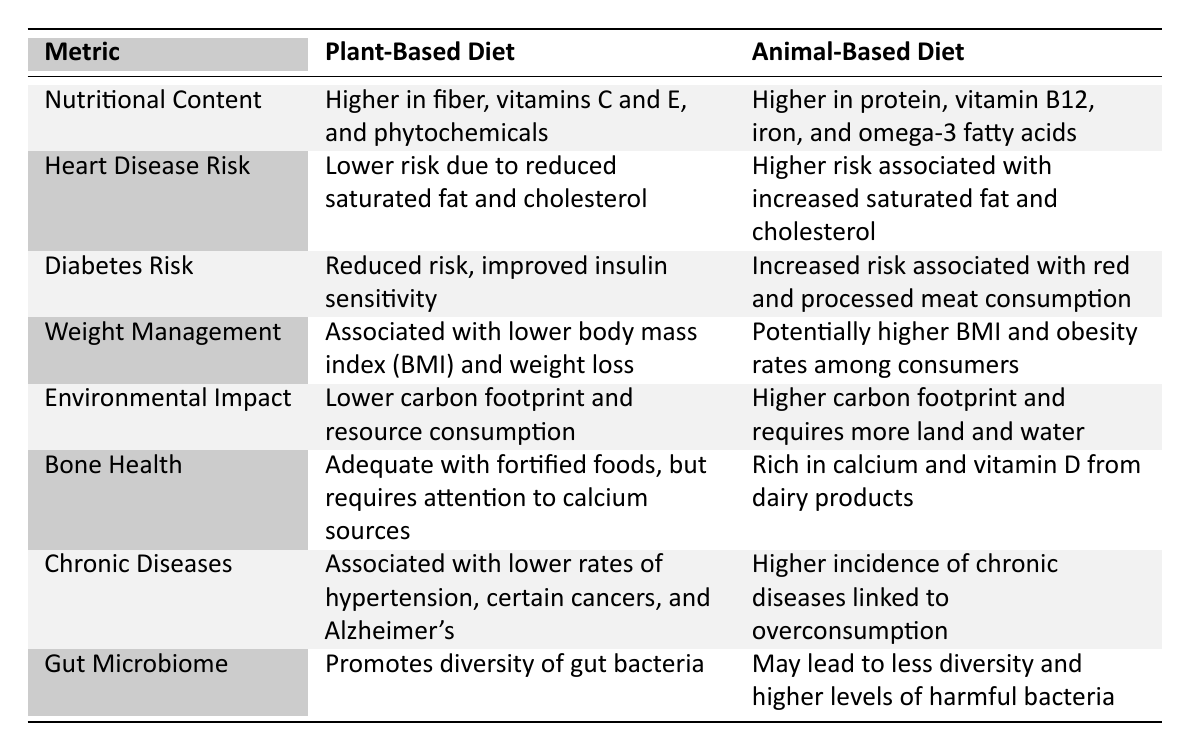What are the two main nutritional benefits of a plant-based diet? The table indicates that a plant-based diet is higher in fiber, vitamins C and E, and phytochemicals.
Answer: Higher in fiber, vitamins C and E What is the heart disease risk associated with an animal-based diet? The table states that an animal-based diet has a higher risk associated with increased saturated fat and cholesterol.
Answer: Higher risk Does a plant-based diet contribute to better weight management? Yes, the table indicates that it is associated with a lower body mass index (BMI) and weight loss.
Answer: Yes Which diet promotes a more diverse gut microbiome? According to the table, a plant-based diet promotes diversity of gut bacteria.
Answer: Plant-based diet What is the environmental impact of a plant-based diet compared to an animal-based diet? The table shows that a plant-based diet has a lower carbon footprint and resource consumption, while an animal-based diet has a higher carbon footprint.
Answer: Lower carbon footprint Is there a difference in chronic disease incidence between the two diets? Yes, the table mentions that a plant-based diet is associated with lower rates of chronic diseases, while an animal-based diet has a higher incidence.
Answer: Yes How does the dietary source affect bone health? The plant-based diet can be adequate with fortified foods but requires attention to calcium sources, while the animal-based diet is rich in calcium and vitamin D.
Answer: Plant-based requires attention; animal-based is rich What is the primary nutritional deficiency to watch for in a plant-based diet? The table implies attention is required for calcium sources in a plant-based diet.
Answer: Calcium sources Which diet is linked to a reduced risk of diabetes? The table highlights that a plant-based diet is associated with reduced risk and improved insulin sensitivity.
Answer: Plant-based diet How do the risks of high saturated fat differ between the two diets? The animal-based diet has a higher risk associated with increased saturated fat and cholesterol, while the plant-based diet has a lower risk.
Answer: Higher in animal-based diet 